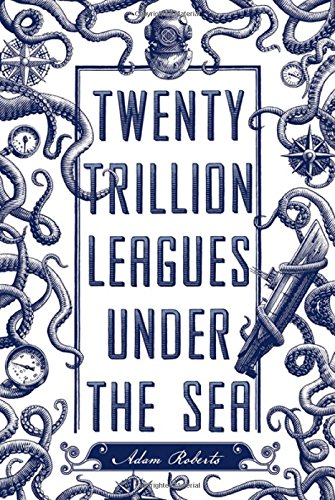Who wrote this book? The book 'Twenty Trillion Leagues Under the Sea' is authored by Adam Roberts, a prolific writer known for his contributions to the science fiction genre. 